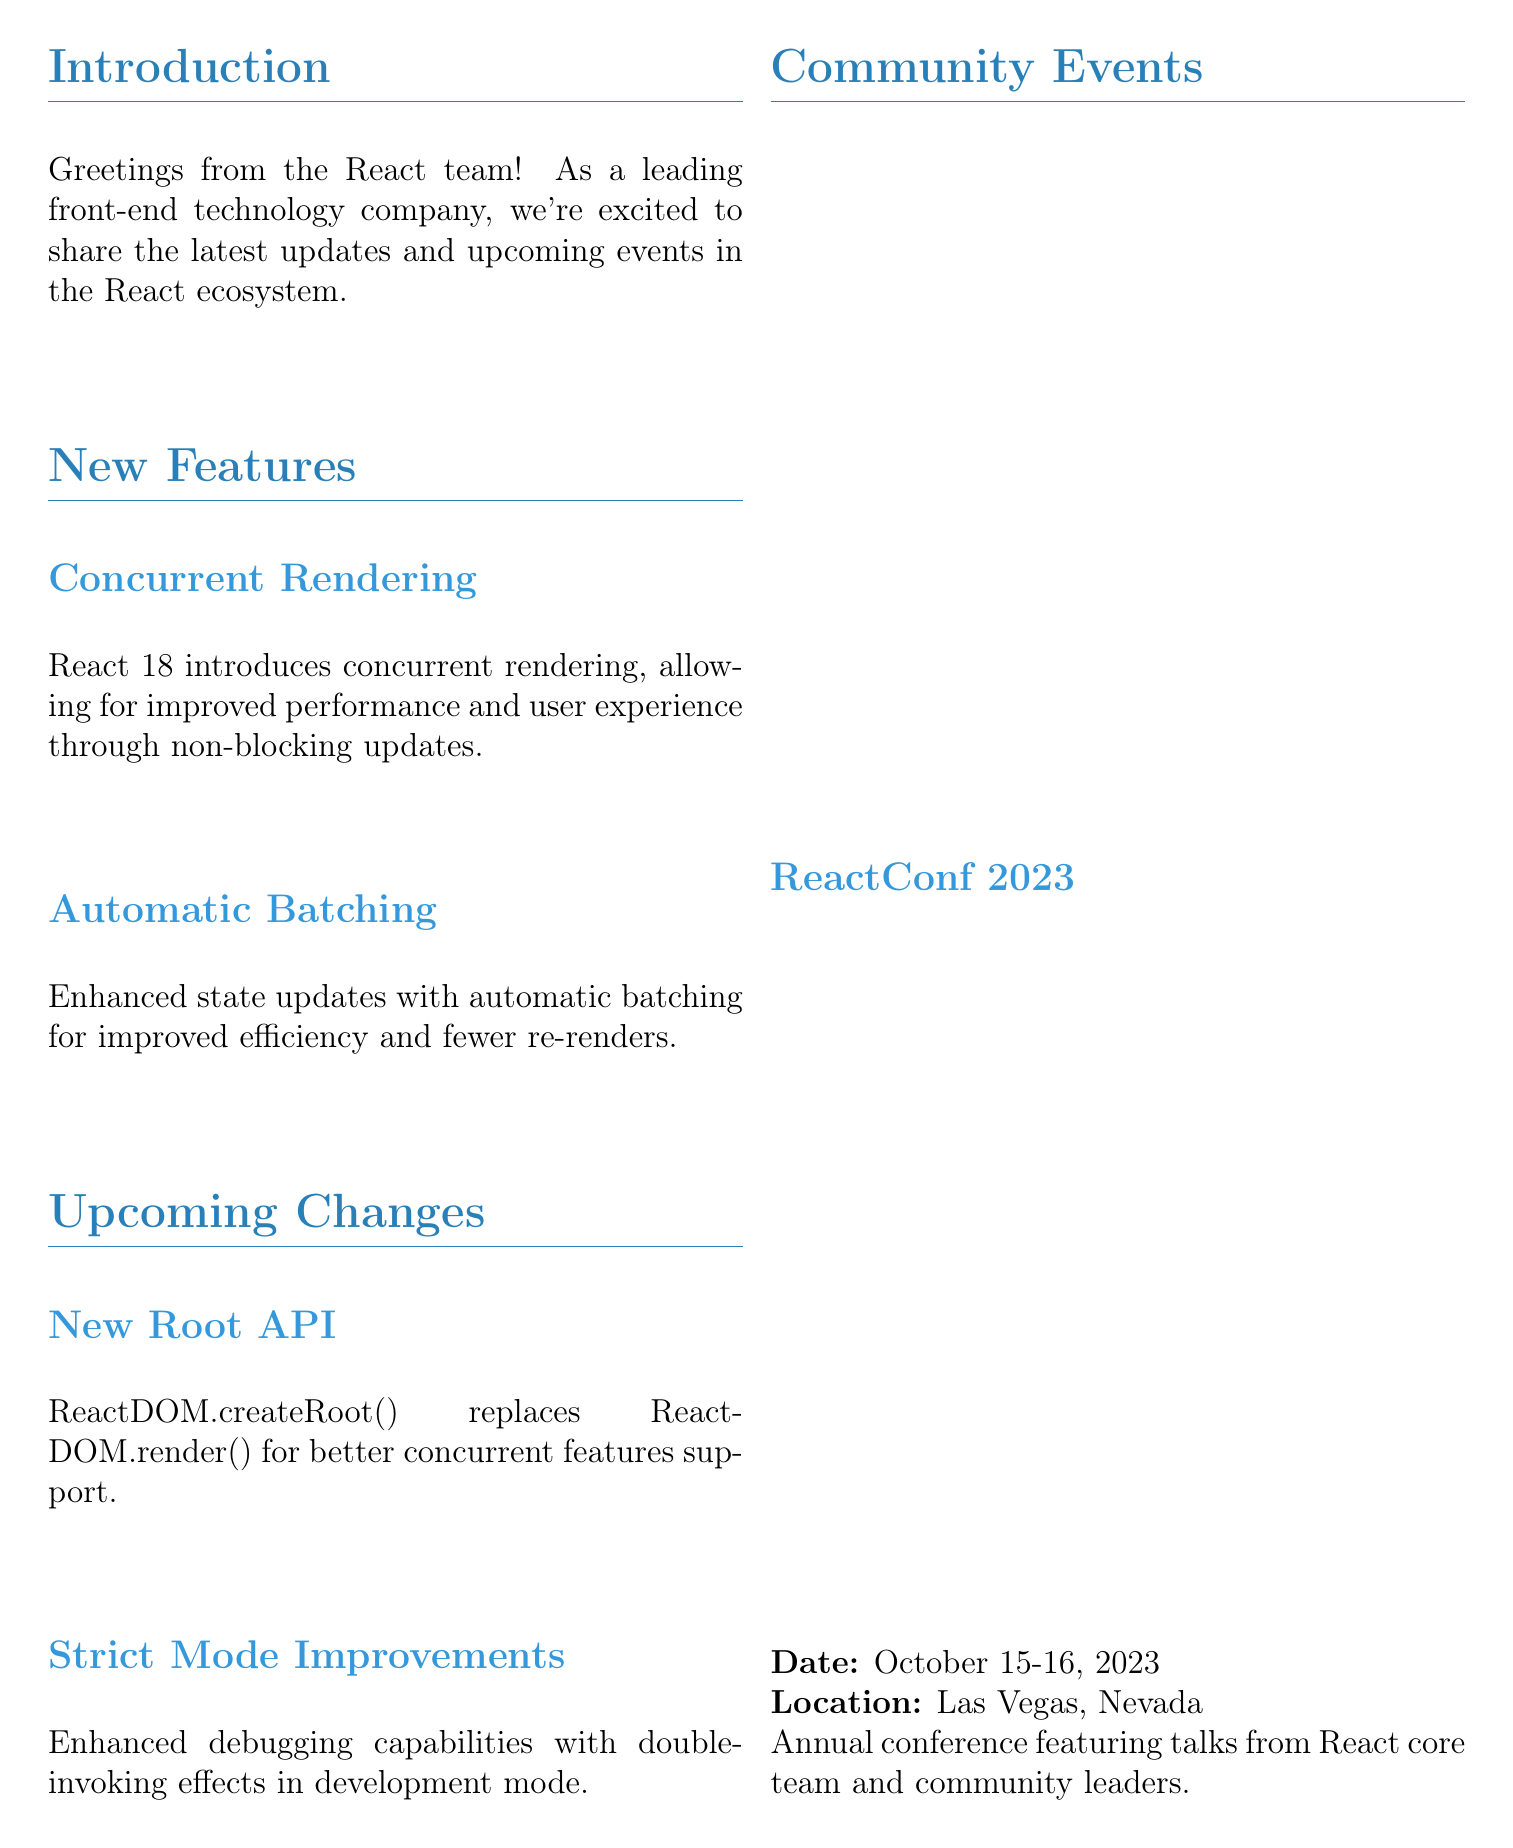What is the title of the newsletter? The title of the newsletter is mentioned at the top of the document.
Answer: React 18 Update What is the date for ReactConf 2023? This date is included in the community events section of the document.
Answer: October 15-16, 2023 What new feature improves performance through non-blocking updates? This feature is listed under new features in the document.
Answer: Concurrent Rendering What replaces ReactDOM.render() in the upcoming changes? This information is provided in the upcoming changes section.
Answer: ReactDOM.createRoot() Where is the React Advanced London event taking place? The location of the event is specified in the community events section.
Answer: London, UK What is one of the benefits of automatic batching? This benefit is mentioned in the new features section as an improvement.
Answer: Improved efficiency What organization can people join for collaboration opportunities? This is detailed in the call-to-action section at the end of the document.
Answer: React Developer Network What are the dates for React Advanced London? The dates are listed in the community events part of the document.
Answer: September 8-9, 2023 